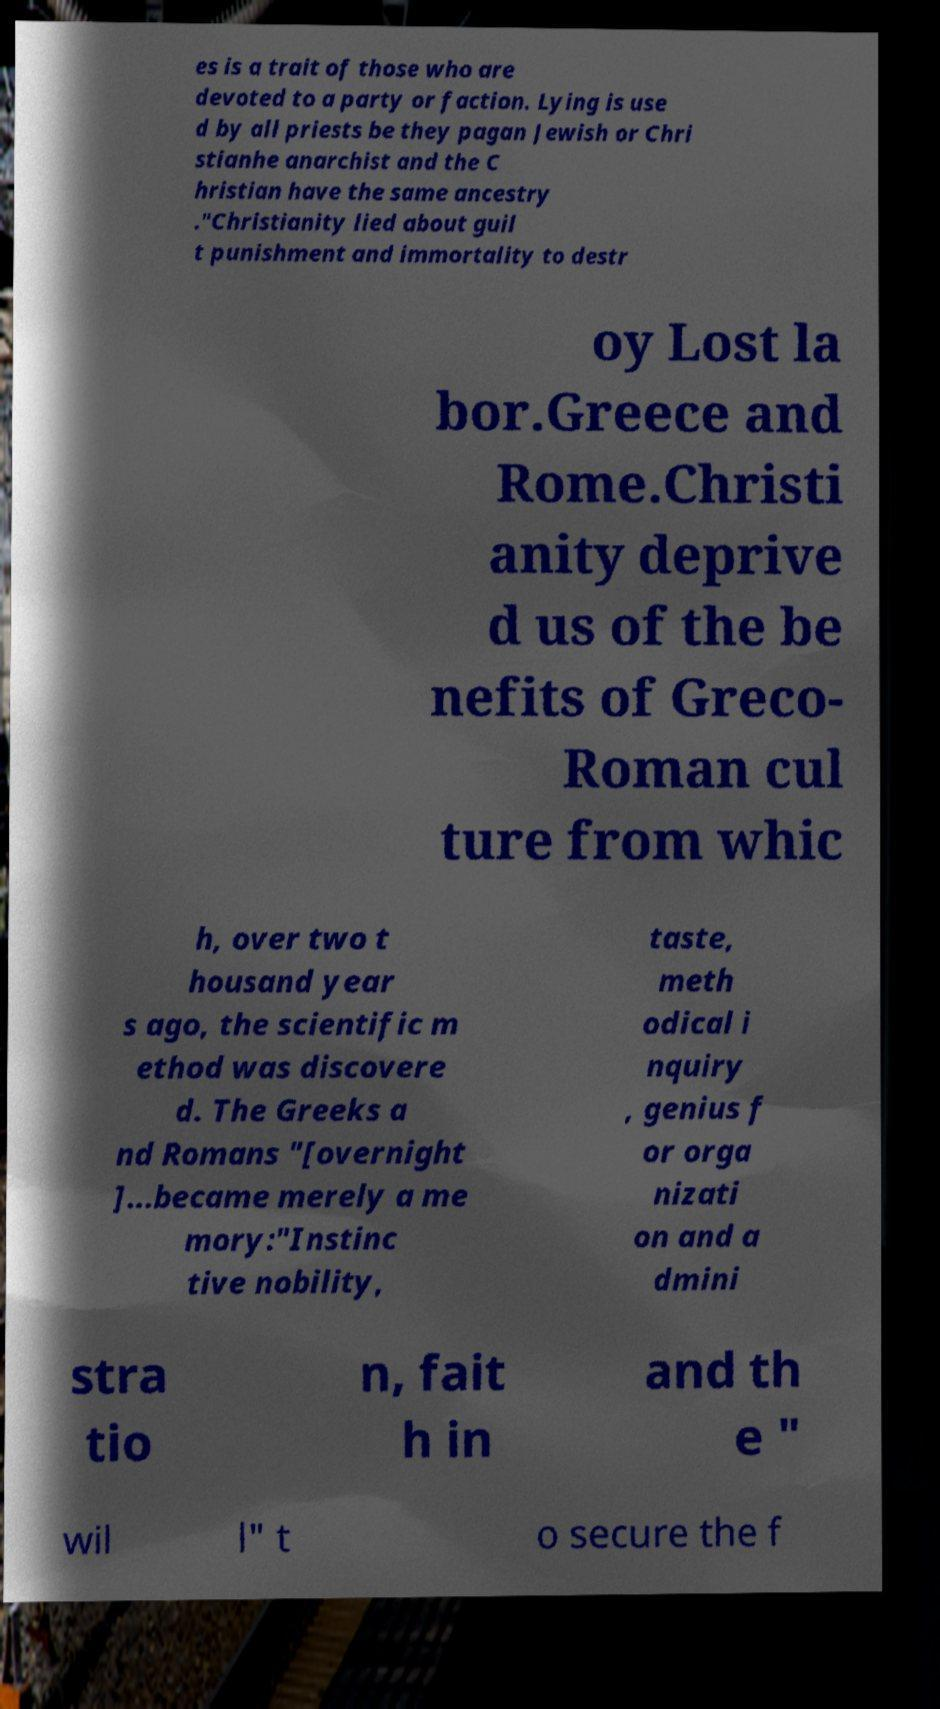Can you accurately transcribe the text from the provided image for me? es is a trait of those who are devoted to a party or faction. Lying is use d by all priests be they pagan Jewish or Chri stianhe anarchist and the C hristian have the same ancestry ."Christianity lied about guil t punishment and immortality to destr oy Lost la bor.Greece and Rome.Christi anity deprive d us of the be nefits of Greco- Roman cul ture from whic h, over two t housand year s ago, the scientific m ethod was discovere d. The Greeks a nd Romans "[overnight ]...became merely a me mory:"Instinc tive nobility, taste, meth odical i nquiry , genius f or orga nizati on and a dmini stra tio n, fait h in and th e " wil l" t o secure the f 